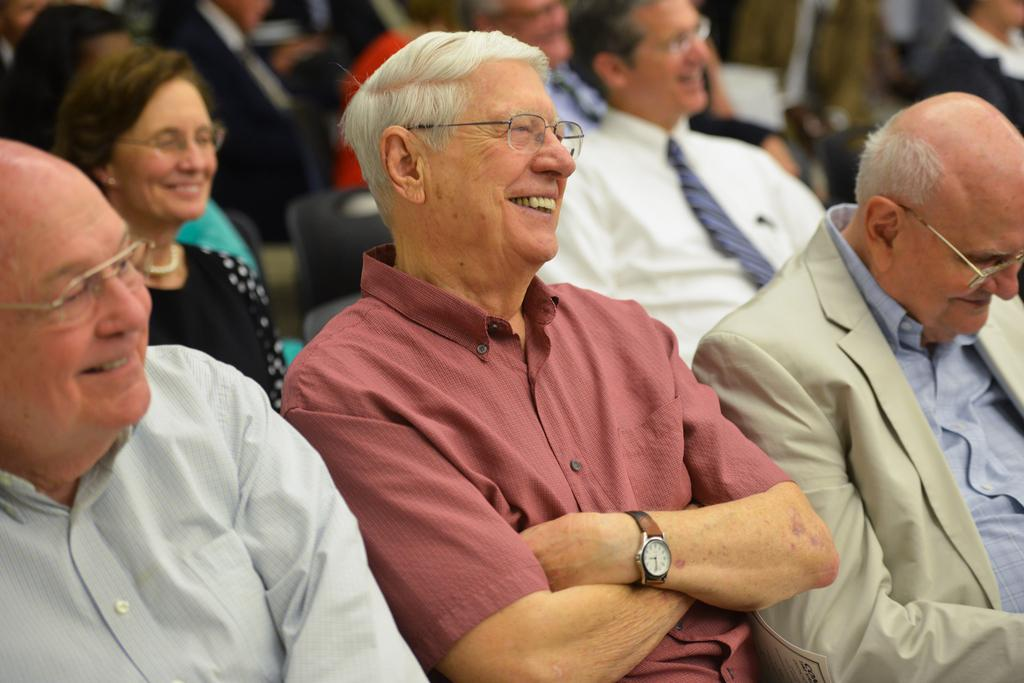How many people are in the image? There is a group of people in the image, but the exact number is not specified. What are the people doing in the image? The people are sitting on chairs and smiling in the image. What can be inferred about the setting of the image? The image may have been taken in a hall, as suggested by the facts. What type of steel is being used to support the skin of the people in the image? There is no mention of steel or skin in the image, and therefore this question cannot be answered. 